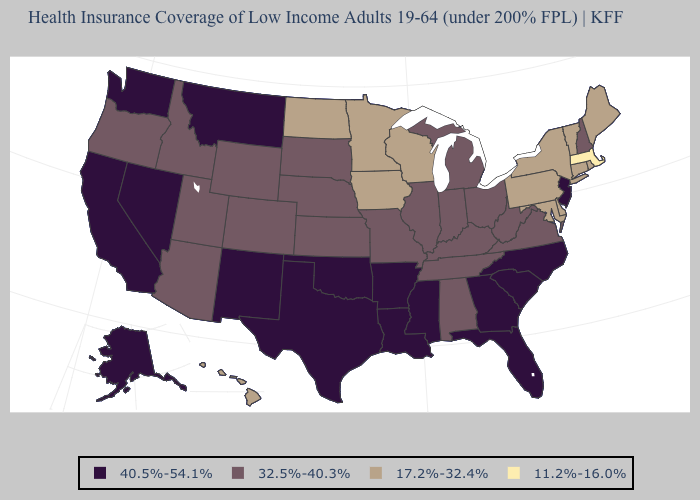What is the highest value in states that border North Carolina?
Keep it brief. 40.5%-54.1%. Name the states that have a value in the range 11.2%-16.0%?
Give a very brief answer. Massachusetts. What is the value of New Jersey?
Keep it brief. 40.5%-54.1%. Does Massachusetts have the lowest value in the USA?
Quick response, please. Yes. What is the value of Indiana?
Concise answer only. 32.5%-40.3%. What is the value of Georgia?
Answer briefly. 40.5%-54.1%. Among the states that border Oregon , which have the lowest value?
Concise answer only. Idaho. What is the highest value in the USA?
Give a very brief answer. 40.5%-54.1%. What is the value of Virginia?
Concise answer only. 32.5%-40.3%. Does the map have missing data?
Concise answer only. No. Does Georgia have the highest value in the USA?
Short answer required. Yes. Does Texas have the lowest value in the USA?
Write a very short answer. No. Name the states that have a value in the range 32.5%-40.3%?
Be succinct. Alabama, Arizona, Colorado, Idaho, Illinois, Indiana, Kansas, Kentucky, Michigan, Missouri, Nebraska, New Hampshire, Ohio, Oregon, South Dakota, Tennessee, Utah, Virginia, West Virginia, Wyoming. Name the states that have a value in the range 32.5%-40.3%?
Short answer required. Alabama, Arizona, Colorado, Idaho, Illinois, Indiana, Kansas, Kentucky, Michigan, Missouri, Nebraska, New Hampshire, Ohio, Oregon, South Dakota, Tennessee, Utah, Virginia, West Virginia, Wyoming. Which states have the lowest value in the USA?
Write a very short answer. Massachusetts. 